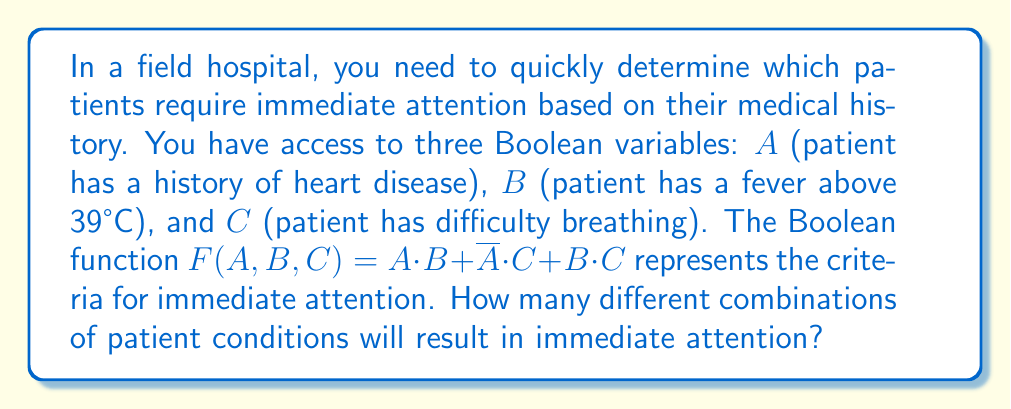Teach me how to tackle this problem. To solve this problem, we'll use the following steps:

1) First, let's create a truth table for the given Boolean function:
   $$F(A,B,C) = A \cdot B + \overline{A} \cdot C + B \cdot C$$

2) The truth table will have 8 rows (2^3 combinations):

   | A | B | C | $A \cdot B$ | $\overline{A} \cdot C$ | $B \cdot C$ | F |
   |---|---|---|-------------|------------------------|-------------|---|
   | 0 | 0 | 0 |      0      |           0            |      0      | 0 |
   | 0 | 0 | 1 |      0      |           1            |      0      | 1 |
   | 0 | 1 | 0 |      0      |           0            |      0      | 0 |
   | 0 | 1 | 1 |      0      |           1            |      1      | 1 |
   | 1 | 0 | 0 |      0      |           0            |      0      | 0 |
   | 1 | 0 | 1 |      0      |           0            |      0      | 0 |
   | 1 | 1 | 0 |      1      |           0            |      0      | 1 |
   | 1 | 1 | 1 |      1      |           0            |      1      | 1 |

3) Count the number of rows where F = 1. This represents the number of combinations that result in immediate attention.

4) From the truth table, we can see that F = 1 for 4 different combinations:
   - When A = 0, B = 0, C = 1
   - When A = 0, B = 1, C = 1
   - When A = 1, B = 1, C = 0
   - When A = 1, B = 1, C = 1

Therefore, there are 4 different combinations of patient conditions that will result in immediate attention.
Answer: 4 